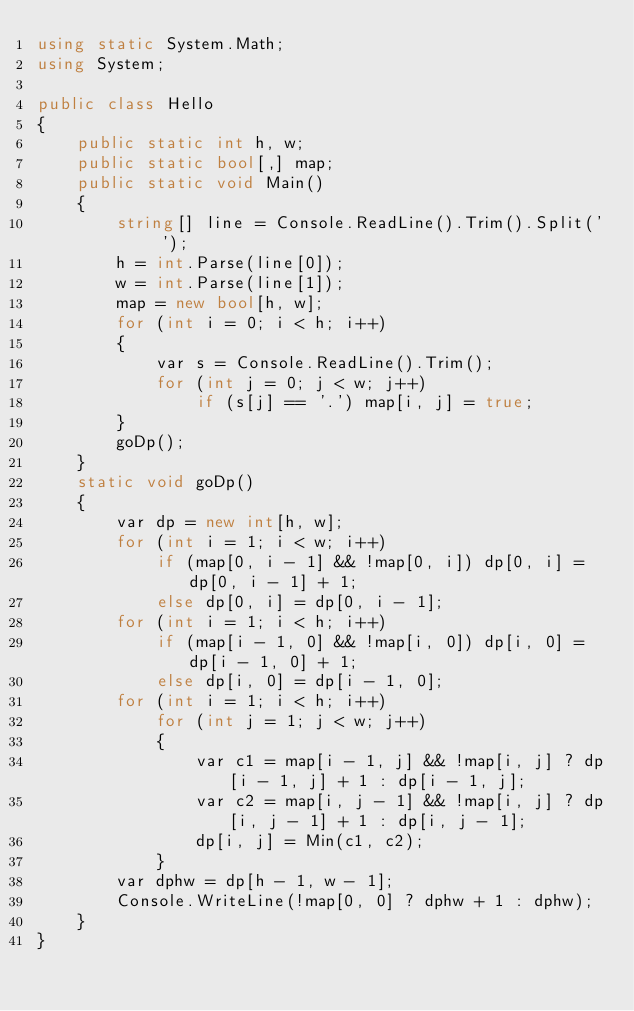Convert code to text. <code><loc_0><loc_0><loc_500><loc_500><_C#_>using static System.Math;
using System;

public class Hello
{
    public static int h, w;
    public static bool[,] map;
    public static void Main()
    {
        string[] line = Console.ReadLine().Trim().Split(' ');
        h = int.Parse(line[0]);
        w = int.Parse(line[1]);
        map = new bool[h, w];
        for (int i = 0; i < h; i++)
        {
            var s = Console.ReadLine().Trim();
            for (int j = 0; j < w; j++)
                if (s[j] == '.') map[i, j] = true;
        }
        goDp();
    }
    static void goDp()
    {
        var dp = new int[h, w];
        for (int i = 1; i < w; i++)
            if (map[0, i - 1] && !map[0, i]) dp[0, i] = dp[0, i - 1] + 1;
            else dp[0, i] = dp[0, i - 1];
        for (int i = 1; i < h; i++)
            if (map[i - 1, 0] && !map[i, 0]) dp[i, 0] = dp[i - 1, 0] + 1;
            else dp[i, 0] = dp[i - 1, 0];
        for (int i = 1; i < h; i++)
            for (int j = 1; j < w; j++)
            {
                var c1 = map[i - 1, j] && !map[i, j] ? dp[i - 1, j] + 1 : dp[i - 1, j];
                var c2 = map[i, j - 1] && !map[i, j] ? dp[i, j - 1] + 1 : dp[i, j - 1];
                dp[i, j] = Min(c1, c2);
            }
        var dphw = dp[h - 1, w - 1];
        Console.WriteLine(!map[0, 0] ? dphw + 1 : dphw);
    }
}
</code> 